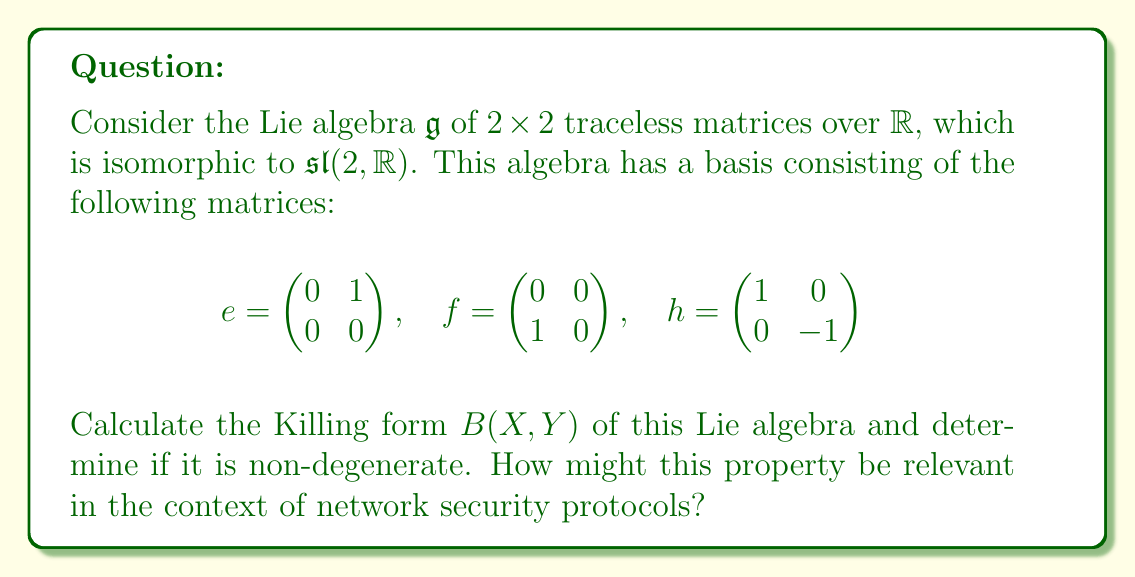Help me with this question. To solve this problem, we'll follow these steps:

1) Recall that the Killing form is defined as $B(X,Y) = \text{tr}(\text{ad}(X) \circ \text{ad}(Y))$, where $\text{ad}(X)(Z) = [X,Z]$ is the adjoint representation.

2) First, we need to calculate the adjoint representations of the basis elements:

   $\text{ad}(e) = \begin{pmatrix} 0 & 2 & 0 \\ 0 & 0 & -1 \\ 0 & 0 & 0 \end{pmatrix}$

   $\text{ad}(f) = \begin{pmatrix} 0 & 0 & 0 \\ -2 & 0 & 0 \\ 0 & 1 & 0 \end{pmatrix}$

   $\text{ad}(h) = \begin{pmatrix} 2 & 0 & 0 \\ 0 & -2 & 0 \\ 0 & 0 & 0 \end{pmatrix}$

3) Now, we can calculate the Killing form for each pair of basis elements:

   $B(e,e) = \text{tr}(\text{ad}(e) \circ \text{ad}(e)) = 0$
   $B(f,f) = \text{tr}(\text{ad}(f) \circ \text{ad}(f)) = 0$
   $B(h,h) = \text{tr}(\text{ad}(h) \circ \text{ad}(h)) = 8$
   $B(e,f) = B(f,e) = \text{tr}(\text{ad}(e) \circ \text{ad}(f)) = 4$
   $B(e,h) = B(h,e) = \text{tr}(\text{ad}(e) \circ \text{ad}(h)) = 0$
   $B(f,h) = B(h,f) = \text{tr}(\text{ad}(f) \circ \text{ad}(h)) = 0$

4) The Killing form can be represented as a matrix:

   $B = \begin{pmatrix} 0 & 4 & 0 \\ 4 & 0 & 0 \\ 0 & 0 & 8 \end{pmatrix}$

5) To determine if the Killing form is non-degenerate, we calculate its determinant:

   $\det(B) = 0 \cdot 0 \cdot 8 - 0 \cdot 0 \cdot 0 - 4 \cdot 4 \cdot 0 + 4 \cdot 0 \cdot 0 + 0 \cdot 4 \cdot 0 + 0 \cdot 0 \cdot 0 = -128$

   Since the determinant is non-zero, the Killing form is non-degenerate.

6) In the context of network security, non-degenerate bilinear forms like this Killing form can be used in cryptographic protocols. For example, they can be utilized in the construction of secure hash functions or in the design of digital signature schemes. The non-degeneracy property ensures that the form doesn't map distinct elements to the same value, which is crucial for maintaining the uniqueness and security of cryptographic operations.
Answer: The Killing form of the given Lie algebra $\mathfrak{g}$ is:

$$B = \begin{pmatrix} 0 & 4 & 0 \\ 4 & 0 & 0 \\ 0 & 0 & 8 \end{pmatrix}$$

The Killing form is non-degenerate as $\det(B) = -128 \neq 0$. This property can be relevant in network security for designing robust cryptographic protocols, such as secure hash functions or digital signature schemes. 